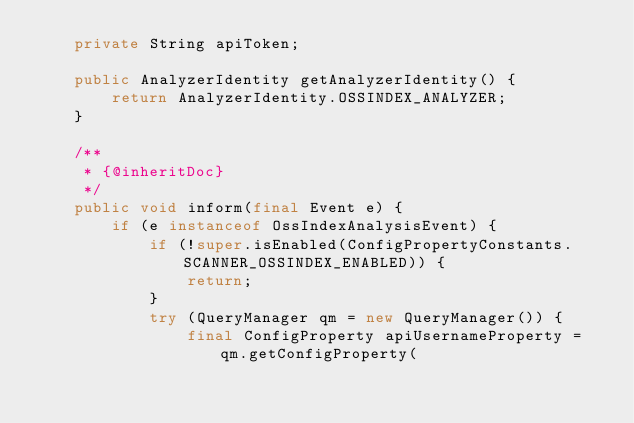Convert code to text. <code><loc_0><loc_0><loc_500><loc_500><_Java_>    private String apiToken;

    public AnalyzerIdentity getAnalyzerIdentity() {
        return AnalyzerIdentity.OSSINDEX_ANALYZER;
    }

    /**
     * {@inheritDoc}
     */
    public void inform(final Event e) {
        if (e instanceof OssIndexAnalysisEvent) {
            if (!super.isEnabled(ConfigPropertyConstants.SCANNER_OSSINDEX_ENABLED)) {
                return;
            }
            try (QueryManager qm = new QueryManager()) {
                final ConfigProperty apiUsernameProperty = qm.getConfigProperty(</code> 